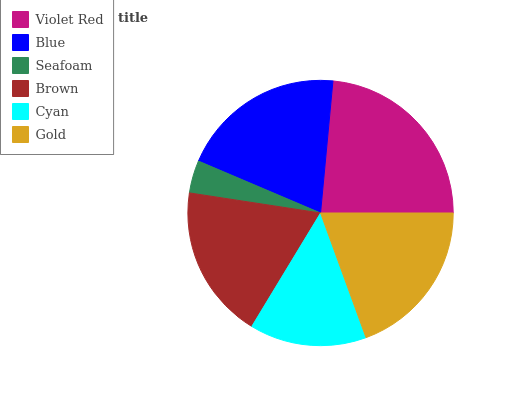Is Seafoam the minimum?
Answer yes or no. Yes. Is Violet Red the maximum?
Answer yes or no. Yes. Is Blue the minimum?
Answer yes or no. No. Is Blue the maximum?
Answer yes or no. No. Is Violet Red greater than Blue?
Answer yes or no. Yes. Is Blue less than Violet Red?
Answer yes or no. Yes. Is Blue greater than Violet Red?
Answer yes or no. No. Is Violet Red less than Blue?
Answer yes or no. No. Is Gold the high median?
Answer yes or no. Yes. Is Brown the low median?
Answer yes or no. Yes. Is Blue the high median?
Answer yes or no. No. Is Seafoam the low median?
Answer yes or no. No. 